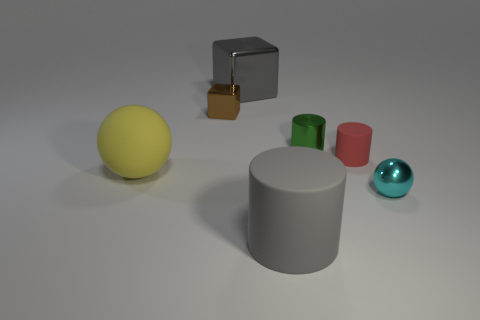Subtract all small red cylinders. How many cylinders are left? 2 Add 1 tiny brown shiny cubes. How many objects exist? 8 Subtract all blocks. How many objects are left? 5 Subtract all cyan cylinders. Subtract all green blocks. How many cylinders are left? 3 Subtract all metallic balls. Subtract all large gray metallic blocks. How many objects are left? 5 Add 7 brown things. How many brown things are left? 8 Add 5 tiny purple rubber spheres. How many tiny purple rubber spheres exist? 5 Subtract 0 green blocks. How many objects are left? 7 